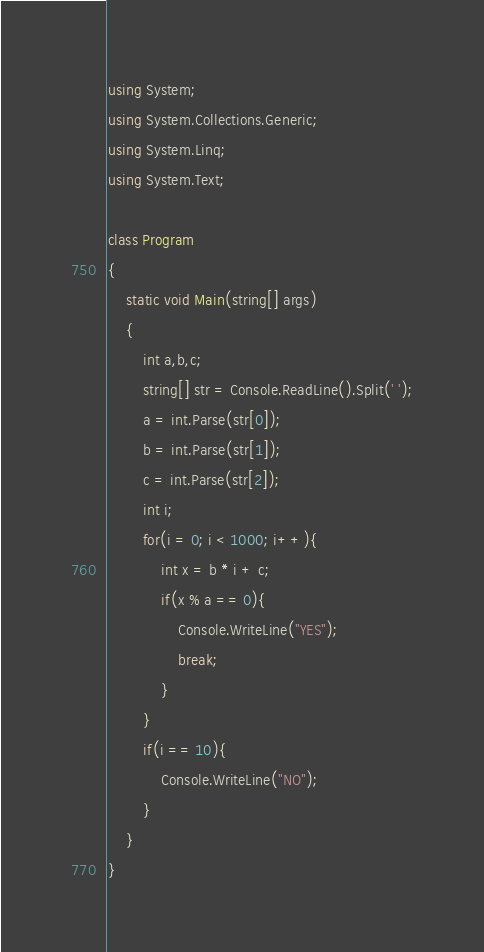<code> <loc_0><loc_0><loc_500><loc_500><_C#_>using System;
using System.Collections.Generic;
using System.Linq;
using System.Text;
 
class Program
{
    static void Main(string[] args)
    {
        int a,b,c;
        string[] str = Console.ReadLine().Split(' ');
        a = int.Parse(str[0]);
        b = int.Parse(str[1]);
        c = int.Parse(str[2]);
        int i;
        for(i = 0; i < 1000; i++){
            int x = b * i + c;
            if(x % a == 0){
                Console.WriteLine("YES");
                break;
            }
        }
        if(i == 10){
            Console.WriteLine("NO");
        }
    }
}</code> 